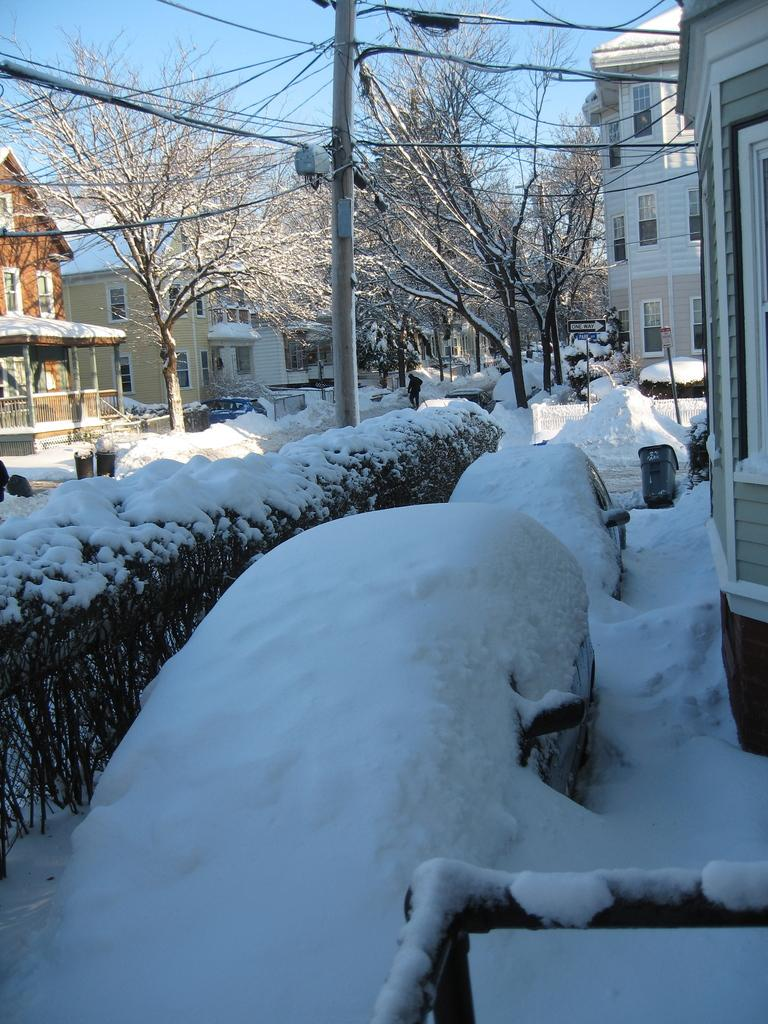What type of structures can be seen in the image? There are buildings in the image. What natural elements are present in the image? There are trees in the image. What is the ground covered with in the image? There is snow at the bottom of the image. What else can be seen in the background of the image? There are wires and sky visible in the background of the image. What object is present in the image that might be used for support or signage? There is a pole in the image. Can you see any clams in the snow in the image? There are no clams present in the image; it features snow, buildings, trees, wires, and a pole. How many geese are flying over the buildings in the image? There are no geese present in the image; it only features buildings, trees, snow, wires, and a pole. 